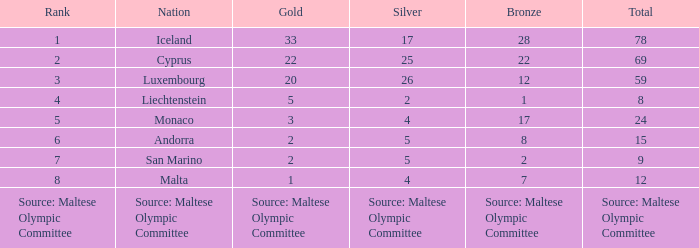What standing is the nation holding 2 silver medals? 4.0. 